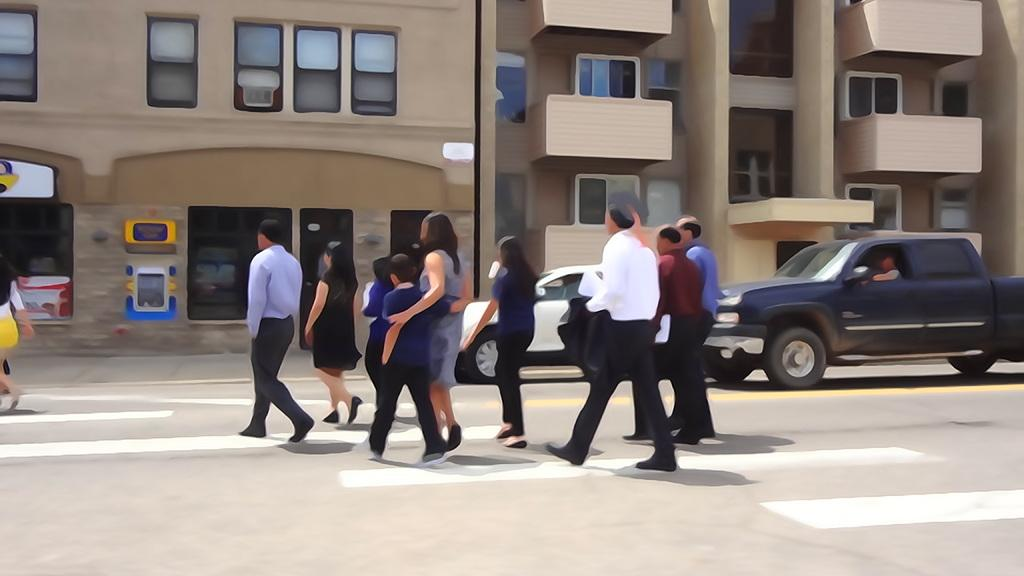What are the people in the image doing? There are persons crossing the road in the image. What else can be seen on the road in the image? There are cars on the road in the image. What structure is visible in the background of the image? There is a building visible in the image. What type of substance is flowing in the stream in the image? There is no stream present in the image; it only features people crossing the road and cars on the road. 